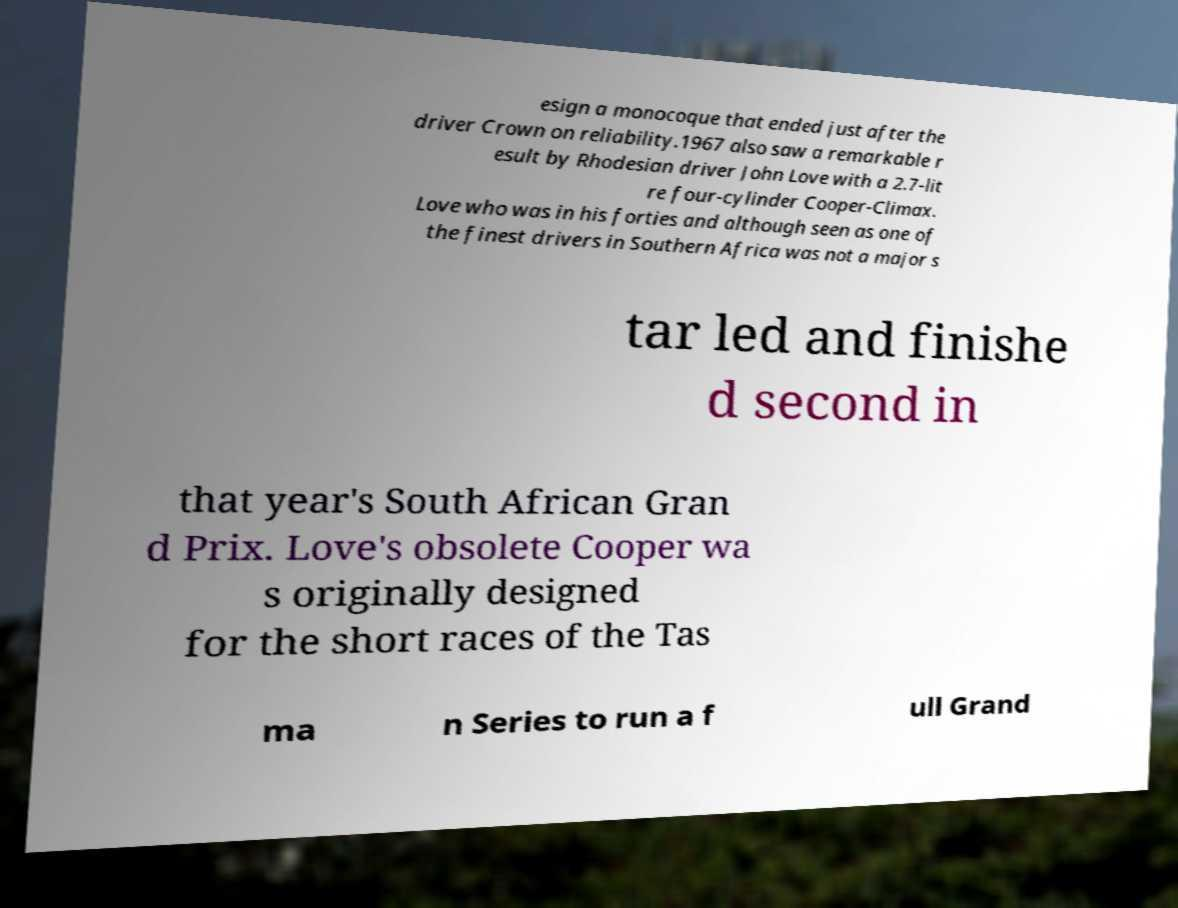What messages or text are displayed in this image? I need them in a readable, typed format. esign a monocoque that ended just after the driver Crown on reliability.1967 also saw a remarkable r esult by Rhodesian driver John Love with a 2.7-lit re four-cylinder Cooper-Climax. Love who was in his forties and although seen as one of the finest drivers in Southern Africa was not a major s tar led and finishe d second in that year's South African Gran d Prix. Love's obsolete Cooper wa s originally designed for the short races of the Tas ma n Series to run a f ull Grand 